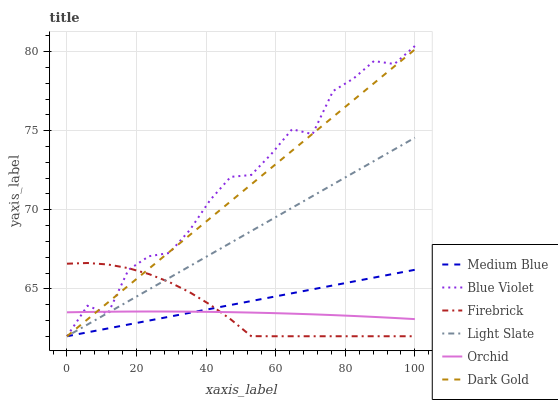Does Orchid have the minimum area under the curve?
Answer yes or no. Yes. Does Blue Violet have the maximum area under the curve?
Answer yes or no. Yes. Does Light Slate have the minimum area under the curve?
Answer yes or no. No. Does Light Slate have the maximum area under the curve?
Answer yes or no. No. Is Medium Blue the smoothest?
Answer yes or no. Yes. Is Blue Violet the roughest?
Answer yes or no. Yes. Is Light Slate the smoothest?
Answer yes or no. No. Is Light Slate the roughest?
Answer yes or no. No. Does Dark Gold have the lowest value?
Answer yes or no. Yes. Does Orchid have the lowest value?
Answer yes or no. No. Does Blue Violet have the highest value?
Answer yes or no. Yes. Does Light Slate have the highest value?
Answer yes or no. No. Does Light Slate intersect Firebrick?
Answer yes or no. Yes. Is Light Slate less than Firebrick?
Answer yes or no. No. Is Light Slate greater than Firebrick?
Answer yes or no. No. 